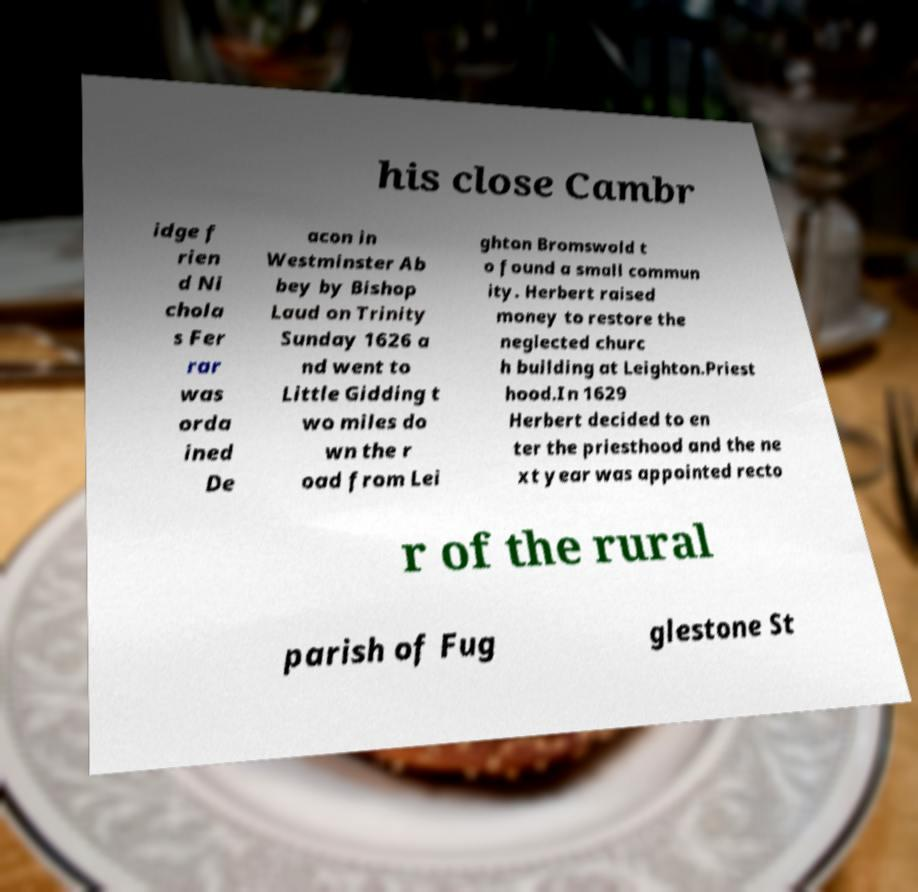Could you assist in decoding the text presented in this image and type it out clearly? his close Cambr idge f rien d Ni chola s Fer rar was orda ined De acon in Westminster Ab bey by Bishop Laud on Trinity Sunday 1626 a nd went to Little Gidding t wo miles do wn the r oad from Lei ghton Bromswold t o found a small commun ity. Herbert raised money to restore the neglected churc h building at Leighton.Priest hood.In 1629 Herbert decided to en ter the priesthood and the ne xt year was appointed recto r of the rural parish of Fug glestone St 